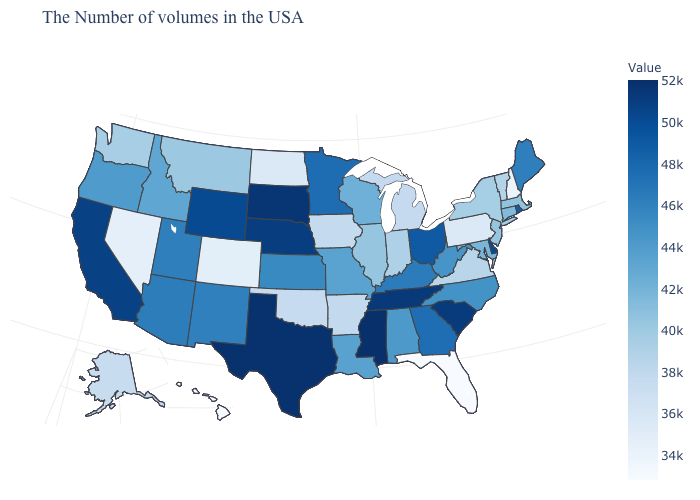Among the states that border Minnesota , which have the lowest value?
Write a very short answer. North Dakota. Does Washington have the lowest value in the USA?
Be succinct. No. Which states have the lowest value in the USA?
Quick response, please. Florida. Does South Dakota have the highest value in the MidWest?
Write a very short answer. Yes. 